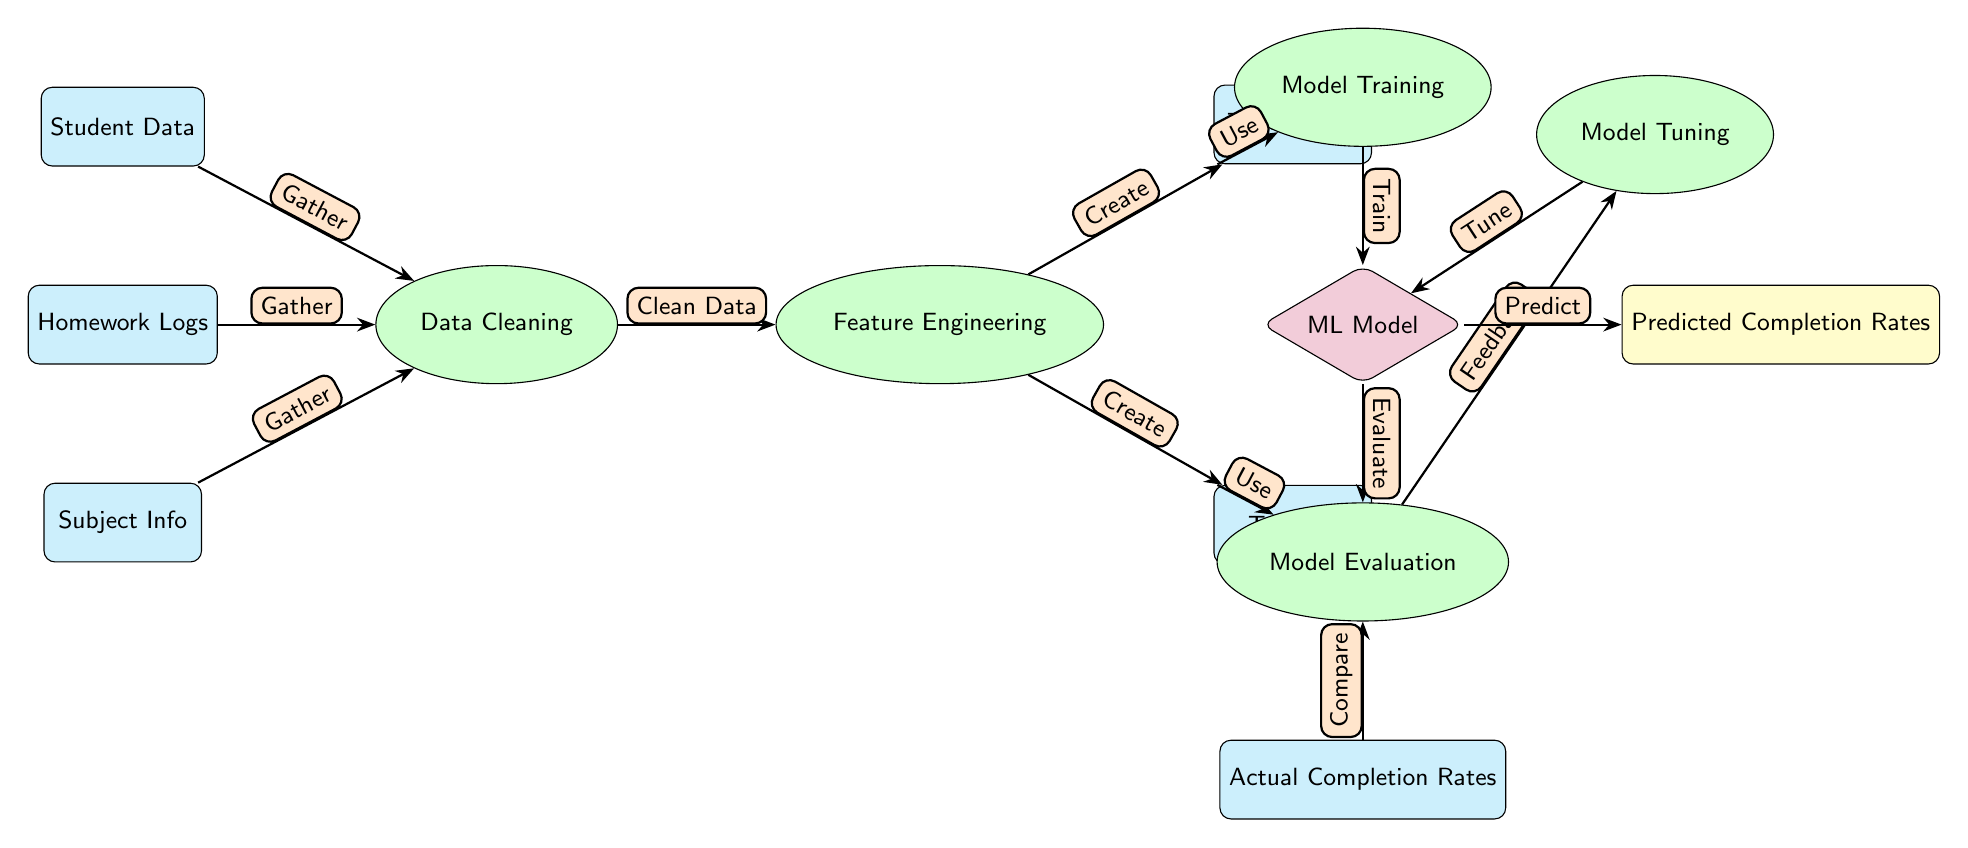What type of model is being used in this diagram? The diagram indicates a "ML Model" is used, situated in a diamond shape to emphasize its role in machine learning processes.
Answer: ML Model How many data nodes are present in the diagram? There are four data nodes: "Student Data," "Homework Logs," "Subject Info," and "Actual Completion Rates." Counting these nodes provides the total.
Answer: 4 What is the first process that follows data gathering? The first process after gathering data from the Student Data, Homework Logs, and Subject Info nodes is "Data Cleaning," which prepares the data for further processing.
Answer: Data Cleaning Which node does the “Model Tuning” process provide feedback to? The "Model Tuning" process gives feedback to the "ML Model" node, as depicted by the edge that flows from "Model Evaluation" to "Model Tuning."
Answer: ML Model What is the output of this entire diagram? The final output of the diagram is "Predicted Completion Rates," represented in a yellow rectangle on the far right.
Answer: Predicted Completion Rates How does the "Test Set" utilize information from the "Feature Engineering" process? The "Test Set" node receives output from the "Feature Engineering" process, as indicated by the directed edge from the Feature Engineering node to the Test Set node, signifying its usage.
Answer: Use What process follows the evaluation of the ML model? After "Model Evaluation," the next process is "Model Tuning," which aims to improve the model based on the evaluation's feedback.
Answer: Model Tuning What is the relationship between "Actual Completion Rates" and "Model Evaluation"? The "Actual Completion Rates" node compares with the "Model Evaluation" node to assess the effectiveness of the predicted rates, as denoted by the edge leading from Actual Completion Rates to Model Evaluation.
Answer: Compare Which three data nodes contribute to the "Data Cleaning" process? The three data nodes that contribute to the "Data Cleaning" process are "Student Data," "Homework Logs," and "Subject Info," as indicated by their directed connections to the Data Cleaning node.
Answer: Student Data, Homework Logs, Subject Info 